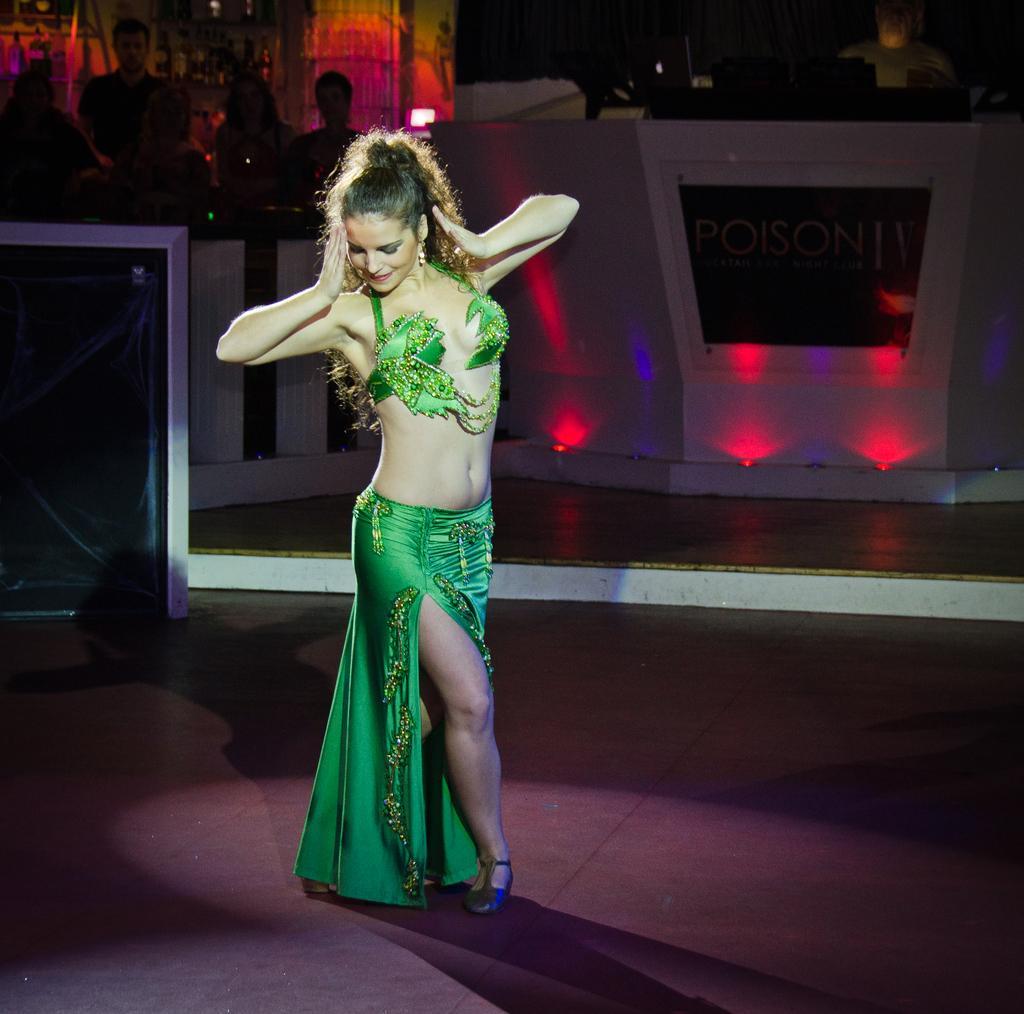Please provide a concise description of this image. In the middle of the image a woman is standing and smiling. Behind her few people are standing and watching and there is a table. 